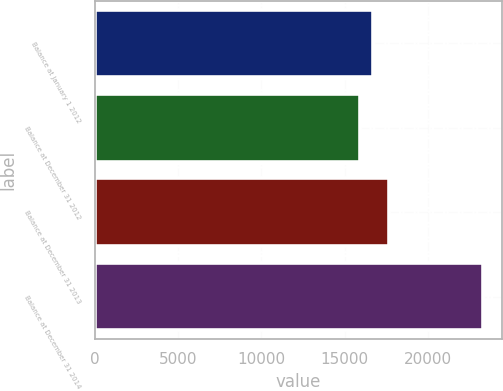Convert chart. <chart><loc_0><loc_0><loc_500><loc_500><bar_chart><fcel>Balance at January 1 2012<fcel>Balance at December 31 2012<fcel>Balance at December 31 2013<fcel>Balance at December 31 2014<nl><fcel>16673.1<fcel>15937<fcel>17671<fcel>23298<nl></chart> 